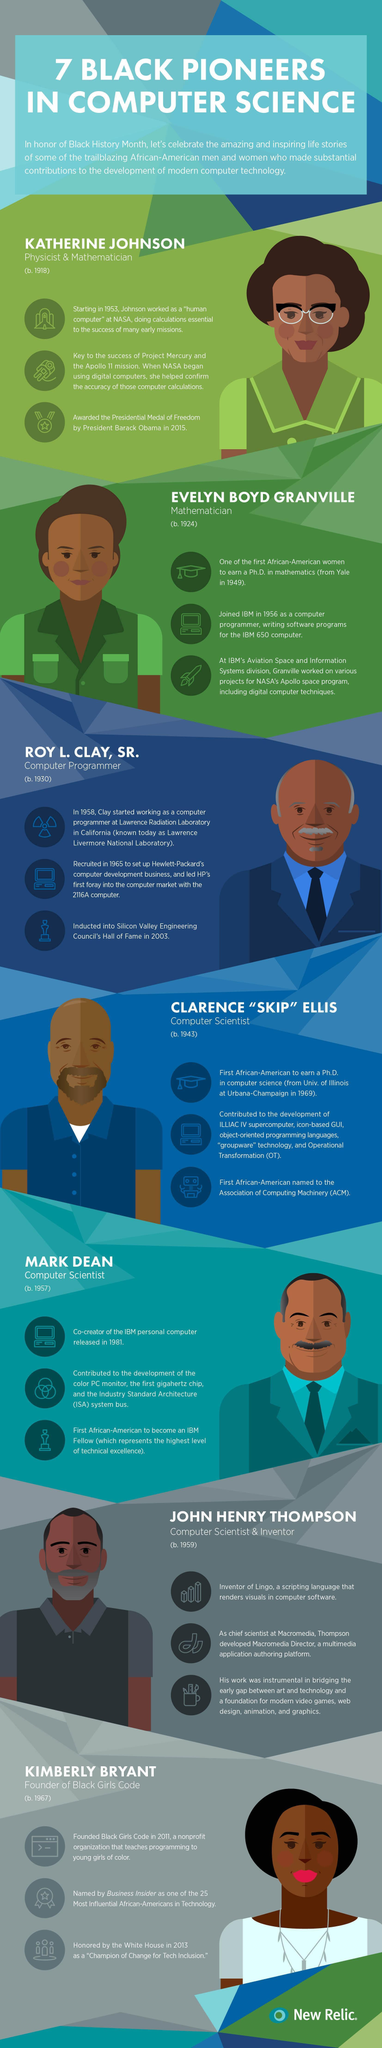How many men are in this infographic?
Answer the question with a short phrase. 4 How many women are in this infographic? 3 How many computer scientists mentioned are in this infographic? 3 